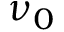Convert formula to latex. <formula><loc_0><loc_0><loc_500><loc_500>\nu _ { 0 }</formula> 